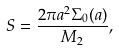<formula> <loc_0><loc_0><loc_500><loc_500>S = \frac { 2 \pi a ^ { 2 } \Sigma _ { 0 } ( a ) } { M _ { 2 } } ,</formula> 